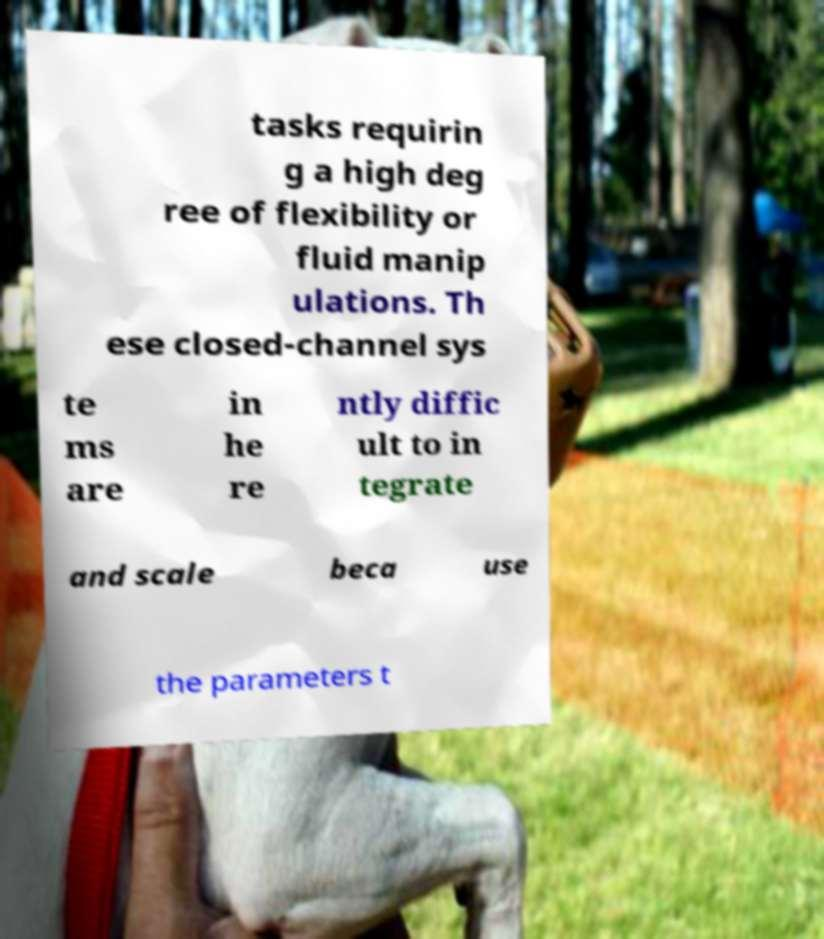Please read and relay the text visible in this image. What does it say? tasks requirin g a high deg ree of flexibility or fluid manip ulations. Th ese closed-channel sys te ms are in he re ntly diffic ult to in tegrate and scale beca use the parameters t 